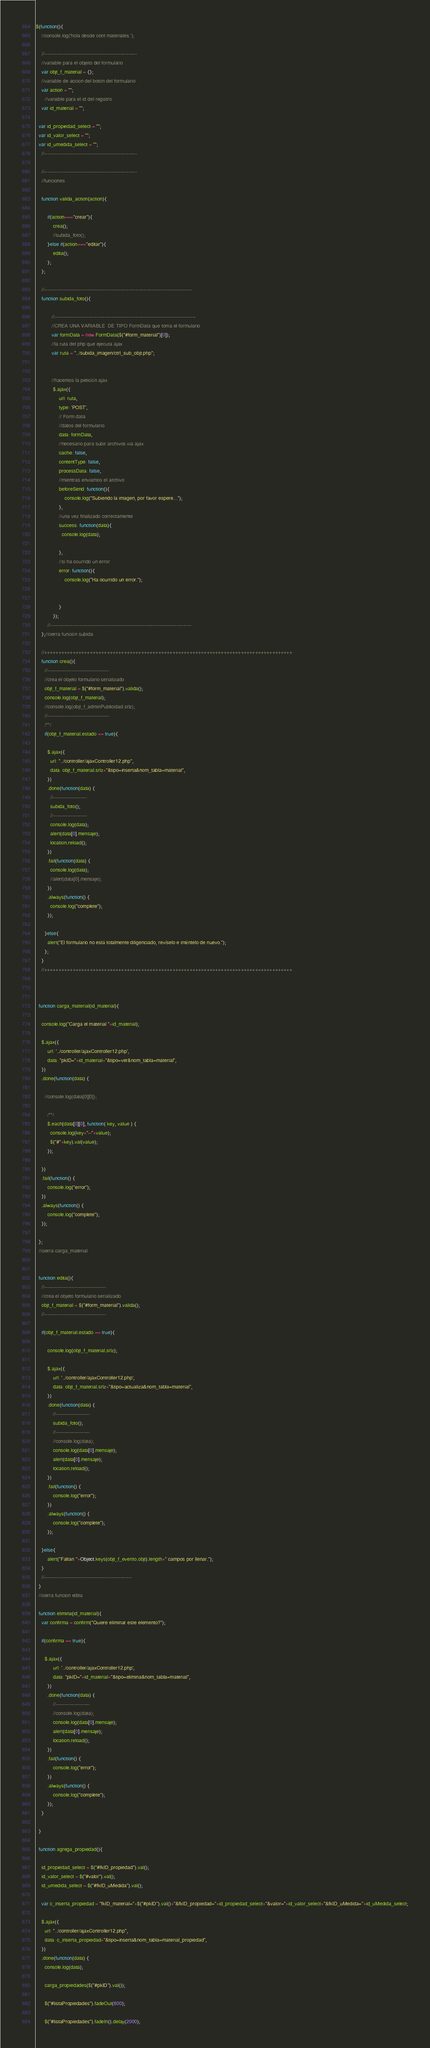<code> <loc_0><loc_0><loc_500><loc_500><_JavaScript_>$(function(){
	//console.log('hola desde cont materiales.');

	//---------------------------------------------------------
	//variable para el objeto del formulario
	var objt_f_material = {};
	//variable de accion del boton del formulario
	var action = "";
	  //variable para el id del registro
	var id_material = "";

  var id_propiedad_select = "";
  var id_valor_select = "";
  var id_umedida_select = "";	
	//---------------------------------------------------------

	//---------------------------------------------------------
	//funciones

	function valida_action(action){

  		if(action==="crear"){
    		crea();
    		//subida_foto();
  		}else if(action==="editar"){
    		edita();
  		};
	};

    //-------------------------------------------------------------------------------------------
    function subida_foto(){

           //---------------------------------------------------------------------------------------
           //CREA UNA VARIABLE  DE TIPO FormData que toma el formulario
           var formData = new FormData($("#form_material")[0]);
           //la ruta del php que ejecuta ajax
           var ruta = "../subida_imagen/ctrl_sub_objt.php";


           //hacemos la petición ajax
            $.ajax({
                url: ruta,
                type: 'POST',
                // Form data
                //datos del formulario
                data: formData,
                //necesario para subir archivos via ajax
                cache: false,
                contentType: false,
                processData: false,
                //mientras enviamos el archivo
                beforeSend: function(){
                    console.log("Subiendo la imagen, por favor espere...");
                },
                //una vez finalizado correctamente
                success: function(data){
                  console.log(data);

                },
                //si ha ocurrido un error
                error: function(){
                    console.log("Ha ocurrido un error.");


                }
            });
		//---------------------------------------------------------------------------------------
    };//cierra función subida

    //+++++++++++++++++++++++++++++++++++++++++++++++++++++++++++++++++++++++++++++++++++++++
    function crea(){
      //--------------------------------------
      //crea el objeto formulario serializado
      objt_f_material = $("#form_material").valida();
      console.log(objt_f_material);
      //console.log(objt_f_adminPublicidad.srlz);
      //--------------------------------------
      /**/
      if(objt_f_material.estado == true){

        $.ajax({
          url: "../controller/ajaxController12.php",
          data: objt_f_material.srlz+"&tipo=inserta&nom_tabla=material",
        })
        .done(function(data) {
          //---------------------
          subida_foto();
          //---------------------
          console.log(data);
          alert(data[0].mensaje);
          location.reload();          
        })
        .fail(function(data) {
          console.log(data);
          //alert(data[0].mensaje);          
        })
        .always(function() {
          console.log("complete");
        });

      }else{
        alert("El formulario no está totalmente diligenciado, revíselo e inténtelo de nuevo.");
      };
    }
    //+++++++++++++++++++++++++++++++++++++++++++++++++++++++++++++++++++++++++++++++++++++++

    

  function carga_material(id_material){

    console.log("Carga el material "+id_material);

    $.ajax({
        url: '../controller/ajaxController12.php',
        data: "pkID="+id_material+"&tipo=ver&nom_tabla=material",
    })
    .done(function(data) {

      //console.log(data[0][0]);

        /**/
        $.each(data[0][0], function( key, value ) {
          console.log(key+"--"+value);
          $("#"+key).val(value);
        }); 

    })
    .fail(function() {
        console.log("error");
    })
    .always(function() {
        console.log("complete");
    });

  };
  //cierra carga_material

  
  function edita(){
    //--------------------------------------
    //crea el objeto formulario serializado
    objt_f_material = $("#form_material").valida();
    //--------------------------------------

    if(objt_f_material.estado == true){

        console.log(objt_f_material.srlz);

        $.ajax({
            url: '../controller/ajaxController12.php',
            data: objt_f_material.srlz+"&tipo=actualiza&nom_tabla=material",
        })
        .done(function(data) {
            //---------------------
            subida_foto();
            //---------------------
            //console.log(data);
            console.log(data[0].mensaje);
            alert(data[0].mensaje);
            location.reload();
        })
        .fail(function() {
            console.log("error");
        })
        .always(function() {
            console.log("complete");
        });

    }else{
        alert("Faltan "+Object.keys(objt_f_evento.objt).length+" campos por llenar.");
    }
    //------------------------------------------------------
  }
  //cierra funcion edita

  function elimina(id_material){
    var confirma = confirm("Quiere eliminar este elemento?");

    if(confirma == true){

      $.ajax({
            url: '../controller/ajaxController12.php',
            data: "pkID="+id_material+"&tipo=elimina&nom_tabla=material",
        })
        .done(function(data) {
            //---------------------
            //console.log(data);
            console.log(data[0].mensaje);
            alert(data[0].mensaje);
            location.reload();
        })
        .fail(function() {
            console.log("error");
        })
        .always(function() {
            console.log("complete");
        });
    }

  }

  function agrega_propiedad(){

    id_propiedad_select = $("#fkID_propiedad").val();
    id_valor_select = $("#valor").val();
    id_umedida_select = $("#fkID_uMedida").val();

    var c_inserta_propiedad = "fkID_material="+$("#pkID").val()+"&fkID_propiedad="+id_propiedad_select+"&valor="+id_valor_select+"&fkID_uMedida="+id_uMedida_select;

    $.ajax({
      url: "../controller/ajaxController12.php",
      data: c_inserta_propiedad+"&tipo=inserta&nom_tabla=material_propiedad",
    })
    .done(function(data) {
      console.log(data);

      carga_propiedades($("#pkID").val());

      $("#listaPropiedades").fadeOut(800);

      $("#listaPropiedades").fadeIn().delay(2000);
</code> 